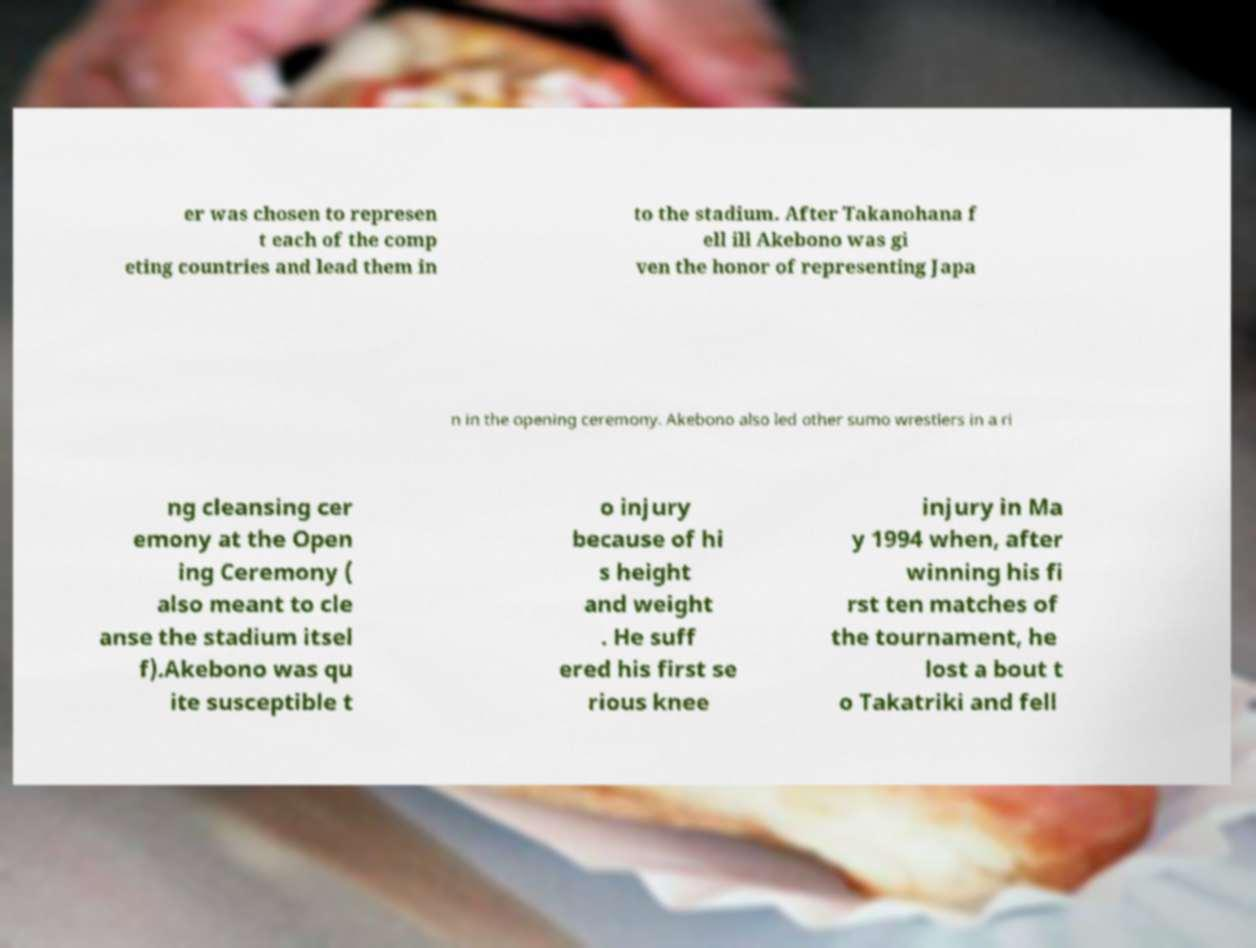Please identify and transcribe the text found in this image. er was chosen to represen t each of the comp eting countries and lead them in to the stadium. After Takanohana f ell ill Akebono was gi ven the honor of representing Japa n in the opening ceremony. Akebono also led other sumo wrestlers in a ri ng cleansing cer emony at the Open ing Ceremony ( also meant to cle anse the stadium itsel f).Akebono was qu ite susceptible t o injury because of hi s height and weight . He suff ered his first se rious knee injury in Ma y 1994 when, after winning his fi rst ten matches of the tournament, he lost a bout t o Takatriki and fell 